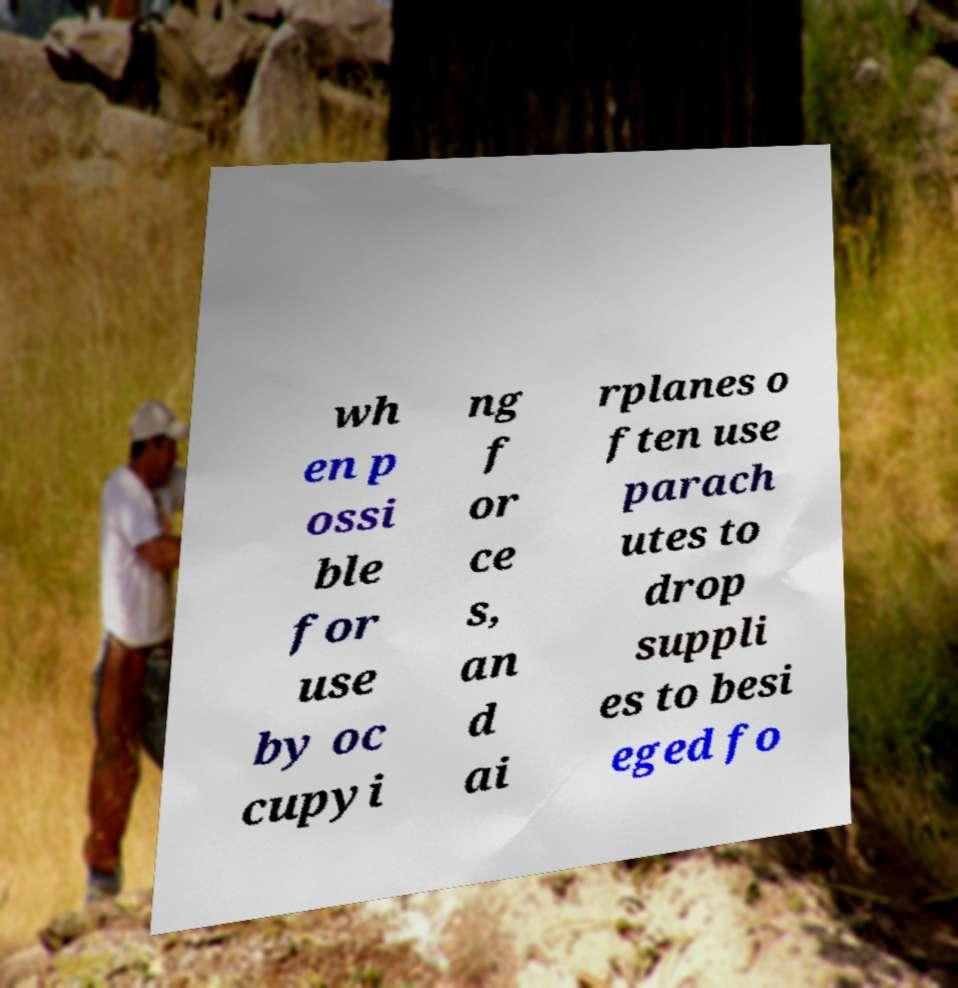Could you assist in decoding the text presented in this image and type it out clearly? wh en p ossi ble for use by oc cupyi ng f or ce s, an d ai rplanes o ften use parach utes to drop suppli es to besi eged fo 